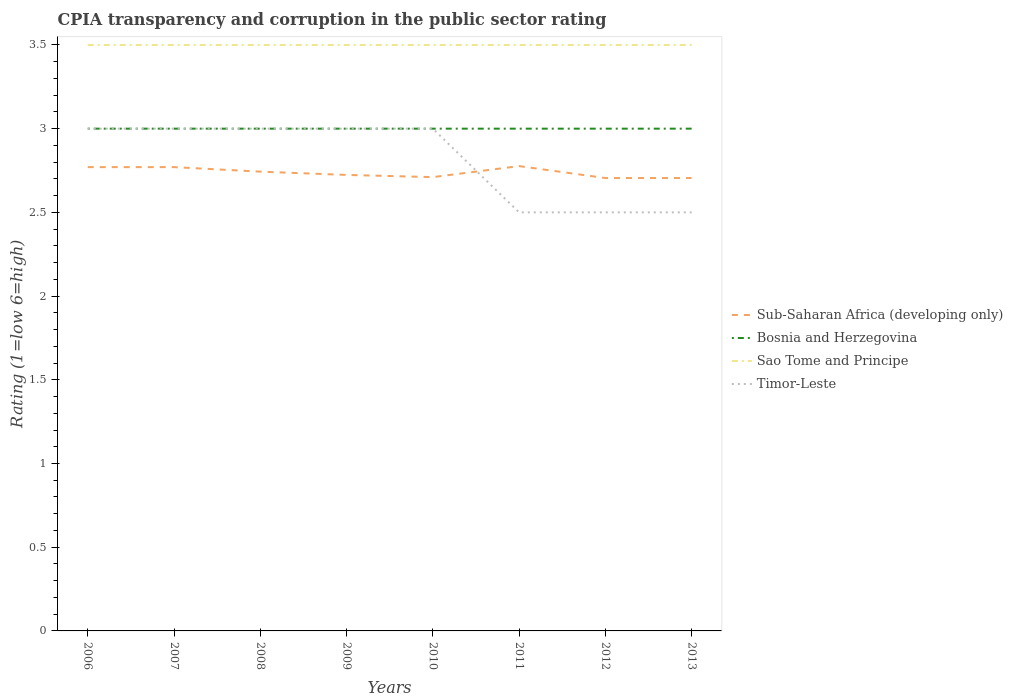Does the line corresponding to Sao Tome and Principe intersect with the line corresponding to Timor-Leste?
Offer a terse response. No. In which year was the CPIA rating in Timor-Leste maximum?
Provide a short and direct response. 2011. Is the CPIA rating in Sub-Saharan Africa (developing only) strictly greater than the CPIA rating in Bosnia and Herzegovina over the years?
Provide a succinct answer. Yes. How many years are there in the graph?
Provide a short and direct response. 8. What is the difference between two consecutive major ticks on the Y-axis?
Keep it short and to the point. 0.5. Does the graph contain grids?
Your answer should be very brief. No. How many legend labels are there?
Offer a terse response. 4. What is the title of the graph?
Provide a succinct answer. CPIA transparency and corruption in the public sector rating. Does "Tunisia" appear as one of the legend labels in the graph?
Ensure brevity in your answer.  No. What is the label or title of the X-axis?
Offer a terse response. Years. What is the label or title of the Y-axis?
Ensure brevity in your answer.  Rating (1=low 6=high). What is the Rating (1=low 6=high) of Sub-Saharan Africa (developing only) in 2006?
Provide a short and direct response. 2.77. What is the Rating (1=low 6=high) of Sao Tome and Principe in 2006?
Make the answer very short. 3.5. What is the Rating (1=low 6=high) in Sub-Saharan Africa (developing only) in 2007?
Offer a terse response. 2.77. What is the Rating (1=low 6=high) in Sao Tome and Principe in 2007?
Provide a succinct answer. 3.5. What is the Rating (1=low 6=high) of Sub-Saharan Africa (developing only) in 2008?
Your answer should be compact. 2.74. What is the Rating (1=low 6=high) in Bosnia and Herzegovina in 2008?
Give a very brief answer. 3. What is the Rating (1=low 6=high) in Sub-Saharan Africa (developing only) in 2009?
Your answer should be compact. 2.72. What is the Rating (1=low 6=high) in Bosnia and Herzegovina in 2009?
Your answer should be compact. 3. What is the Rating (1=low 6=high) of Sao Tome and Principe in 2009?
Provide a succinct answer. 3.5. What is the Rating (1=low 6=high) of Sub-Saharan Africa (developing only) in 2010?
Ensure brevity in your answer.  2.71. What is the Rating (1=low 6=high) of Bosnia and Herzegovina in 2010?
Offer a terse response. 3. What is the Rating (1=low 6=high) of Timor-Leste in 2010?
Your answer should be very brief. 3. What is the Rating (1=low 6=high) of Sub-Saharan Africa (developing only) in 2011?
Give a very brief answer. 2.78. What is the Rating (1=low 6=high) in Bosnia and Herzegovina in 2011?
Keep it short and to the point. 3. What is the Rating (1=low 6=high) in Sao Tome and Principe in 2011?
Your response must be concise. 3.5. What is the Rating (1=low 6=high) of Timor-Leste in 2011?
Offer a terse response. 2.5. What is the Rating (1=low 6=high) in Sub-Saharan Africa (developing only) in 2012?
Provide a succinct answer. 2.71. What is the Rating (1=low 6=high) in Sub-Saharan Africa (developing only) in 2013?
Offer a terse response. 2.71. What is the Rating (1=low 6=high) of Sao Tome and Principe in 2013?
Offer a terse response. 3.5. Across all years, what is the maximum Rating (1=low 6=high) of Sub-Saharan Africa (developing only)?
Make the answer very short. 2.78. Across all years, what is the maximum Rating (1=low 6=high) in Bosnia and Herzegovina?
Make the answer very short. 3. Across all years, what is the maximum Rating (1=low 6=high) of Sao Tome and Principe?
Provide a succinct answer. 3.5. Across all years, what is the maximum Rating (1=low 6=high) of Timor-Leste?
Your answer should be very brief. 3. Across all years, what is the minimum Rating (1=low 6=high) in Sub-Saharan Africa (developing only)?
Offer a terse response. 2.71. What is the total Rating (1=low 6=high) in Sub-Saharan Africa (developing only) in the graph?
Keep it short and to the point. 21.9. What is the difference between the Rating (1=low 6=high) in Sub-Saharan Africa (developing only) in 2006 and that in 2008?
Your answer should be compact. 0.03. What is the difference between the Rating (1=low 6=high) of Bosnia and Herzegovina in 2006 and that in 2008?
Provide a succinct answer. 0. What is the difference between the Rating (1=low 6=high) in Sao Tome and Principe in 2006 and that in 2008?
Ensure brevity in your answer.  0. What is the difference between the Rating (1=low 6=high) in Timor-Leste in 2006 and that in 2008?
Provide a short and direct response. 0. What is the difference between the Rating (1=low 6=high) in Sub-Saharan Africa (developing only) in 2006 and that in 2009?
Your answer should be very brief. 0.05. What is the difference between the Rating (1=low 6=high) of Bosnia and Herzegovina in 2006 and that in 2009?
Your answer should be compact. 0. What is the difference between the Rating (1=low 6=high) in Sub-Saharan Africa (developing only) in 2006 and that in 2010?
Your response must be concise. 0.06. What is the difference between the Rating (1=low 6=high) of Sao Tome and Principe in 2006 and that in 2010?
Offer a very short reply. 0. What is the difference between the Rating (1=low 6=high) of Sub-Saharan Africa (developing only) in 2006 and that in 2011?
Make the answer very short. -0.01. What is the difference between the Rating (1=low 6=high) in Bosnia and Herzegovina in 2006 and that in 2011?
Give a very brief answer. 0. What is the difference between the Rating (1=low 6=high) of Sub-Saharan Africa (developing only) in 2006 and that in 2012?
Keep it short and to the point. 0.07. What is the difference between the Rating (1=low 6=high) in Sao Tome and Principe in 2006 and that in 2012?
Offer a very short reply. 0. What is the difference between the Rating (1=low 6=high) of Timor-Leste in 2006 and that in 2012?
Give a very brief answer. 0.5. What is the difference between the Rating (1=low 6=high) in Sub-Saharan Africa (developing only) in 2006 and that in 2013?
Provide a succinct answer. 0.07. What is the difference between the Rating (1=low 6=high) in Bosnia and Herzegovina in 2006 and that in 2013?
Give a very brief answer. 0. What is the difference between the Rating (1=low 6=high) of Sao Tome and Principe in 2006 and that in 2013?
Offer a very short reply. 0. What is the difference between the Rating (1=low 6=high) of Timor-Leste in 2006 and that in 2013?
Make the answer very short. 0.5. What is the difference between the Rating (1=low 6=high) in Sub-Saharan Africa (developing only) in 2007 and that in 2008?
Your response must be concise. 0.03. What is the difference between the Rating (1=low 6=high) in Sao Tome and Principe in 2007 and that in 2008?
Offer a very short reply. 0. What is the difference between the Rating (1=low 6=high) in Timor-Leste in 2007 and that in 2008?
Provide a succinct answer. 0. What is the difference between the Rating (1=low 6=high) of Sub-Saharan Africa (developing only) in 2007 and that in 2009?
Your response must be concise. 0.05. What is the difference between the Rating (1=low 6=high) in Sao Tome and Principe in 2007 and that in 2009?
Give a very brief answer. 0. What is the difference between the Rating (1=low 6=high) in Timor-Leste in 2007 and that in 2009?
Keep it short and to the point. 0. What is the difference between the Rating (1=low 6=high) in Sub-Saharan Africa (developing only) in 2007 and that in 2010?
Your answer should be compact. 0.06. What is the difference between the Rating (1=low 6=high) in Bosnia and Herzegovina in 2007 and that in 2010?
Give a very brief answer. 0. What is the difference between the Rating (1=low 6=high) in Sao Tome and Principe in 2007 and that in 2010?
Provide a succinct answer. 0. What is the difference between the Rating (1=low 6=high) in Sub-Saharan Africa (developing only) in 2007 and that in 2011?
Offer a terse response. -0.01. What is the difference between the Rating (1=low 6=high) of Sao Tome and Principe in 2007 and that in 2011?
Ensure brevity in your answer.  0. What is the difference between the Rating (1=low 6=high) of Timor-Leste in 2007 and that in 2011?
Your response must be concise. 0.5. What is the difference between the Rating (1=low 6=high) of Sub-Saharan Africa (developing only) in 2007 and that in 2012?
Give a very brief answer. 0.07. What is the difference between the Rating (1=low 6=high) of Bosnia and Herzegovina in 2007 and that in 2012?
Keep it short and to the point. 0. What is the difference between the Rating (1=low 6=high) in Sao Tome and Principe in 2007 and that in 2012?
Provide a succinct answer. 0. What is the difference between the Rating (1=low 6=high) of Sub-Saharan Africa (developing only) in 2007 and that in 2013?
Your answer should be compact. 0.07. What is the difference between the Rating (1=low 6=high) in Sao Tome and Principe in 2007 and that in 2013?
Your response must be concise. 0. What is the difference between the Rating (1=low 6=high) in Timor-Leste in 2007 and that in 2013?
Provide a succinct answer. 0.5. What is the difference between the Rating (1=low 6=high) in Sub-Saharan Africa (developing only) in 2008 and that in 2009?
Your response must be concise. 0.02. What is the difference between the Rating (1=low 6=high) of Sub-Saharan Africa (developing only) in 2008 and that in 2010?
Your response must be concise. 0.03. What is the difference between the Rating (1=low 6=high) in Sub-Saharan Africa (developing only) in 2008 and that in 2011?
Ensure brevity in your answer.  -0.03. What is the difference between the Rating (1=low 6=high) in Bosnia and Herzegovina in 2008 and that in 2011?
Ensure brevity in your answer.  0. What is the difference between the Rating (1=low 6=high) in Sao Tome and Principe in 2008 and that in 2011?
Keep it short and to the point. 0. What is the difference between the Rating (1=low 6=high) of Timor-Leste in 2008 and that in 2011?
Keep it short and to the point. 0.5. What is the difference between the Rating (1=low 6=high) of Sub-Saharan Africa (developing only) in 2008 and that in 2012?
Offer a very short reply. 0.04. What is the difference between the Rating (1=low 6=high) in Bosnia and Herzegovina in 2008 and that in 2012?
Provide a short and direct response. 0. What is the difference between the Rating (1=low 6=high) in Sao Tome and Principe in 2008 and that in 2012?
Offer a very short reply. 0. What is the difference between the Rating (1=low 6=high) in Sub-Saharan Africa (developing only) in 2008 and that in 2013?
Keep it short and to the point. 0.04. What is the difference between the Rating (1=low 6=high) in Sao Tome and Principe in 2008 and that in 2013?
Your response must be concise. 0. What is the difference between the Rating (1=low 6=high) in Sub-Saharan Africa (developing only) in 2009 and that in 2010?
Give a very brief answer. 0.01. What is the difference between the Rating (1=low 6=high) in Bosnia and Herzegovina in 2009 and that in 2010?
Your response must be concise. 0. What is the difference between the Rating (1=low 6=high) in Sao Tome and Principe in 2009 and that in 2010?
Make the answer very short. 0. What is the difference between the Rating (1=low 6=high) in Sub-Saharan Africa (developing only) in 2009 and that in 2011?
Give a very brief answer. -0.05. What is the difference between the Rating (1=low 6=high) of Bosnia and Herzegovina in 2009 and that in 2011?
Offer a very short reply. 0. What is the difference between the Rating (1=low 6=high) of Sub-Saharan Africa (developing only) in 2009 and that in 2012?
Your answer should be compact. 0.02. What is the difference between the Rating (1=low 6=high) in Bosnia and Herzegovina in 2009 and that in 2012?
Offer a terse response. 0. What is the difference between the Rating (1=low 6=high) in Sao Tome and Principe in 2009 and that in 2012?
Your answer should be compact. 0. What is the difference between the Rating (1=low 6=high) of Sub-Saharan Africa (developing only) in 2009 and that in 2013?
Offer a very short reply. 0.02. What is the difference between the Rating (1=low 6=high) in Sao Tome and Principe in 2009 and that in 2013?
Provide a succinct answer. 0. What is the difference between the Rating (1=low 6=high) of Sub-Saharan Africa (developing only) in 2010 and that in 2011?
Provide a short and direct response. -0.07. What is the difference between the Rating (1=low 6=high) of Bosnia and Herzegovina in 2010 and that in 2011?
Keep it short and to the point. 0. What is the difference between the Rating (1=low 6=high) in Sub-Saharan Africa (developing only) in 2010 and that in 2012?
Your response must be concise. 0.01. What is the difference between the Rating (1=low 6=high) of Bosnia and Herzegovina in 2010 and that in 2012?
Keep it short and to the point. 0. What is the difference between the Rating (1=low 6=high) of Sao Tome and Principe in 2010 and that in 2012?
Make the answer very short. 0. What is the difference between the Rating (1=low 6=high) in Timor-Leste in 2010 and that in 2012?
Ensure brevity in your answer.  0.5. What is the difference between the Rating (1=low 6=high) of Sub-Saharan Africa (developing only) in 2010 and that in 2013?
Offer a very short reply. 0.01. What is the difference between the Rating (1=low 6=high) in Sub-Saharan Africa (developing only) in 2011 and that in 2012?
Give a very brief answer. 0.07. What is the difference between the Rating (1=low 6=high) in Sao Tome and Principe in 2011 and that in 2012?
Give a very brief answer. 0. What is the difference between the Rating (1=low 6=high) of Sub-Saharan Africa (developing only) in 2011 and that in 2013?
Keep it short and to the point. 0.07. What is the difference between the Rating (1=low 6=high) in Sao Tome and Principe in 2011 and that in 2013?
Provide a succinct answer. 0. What is the difference between the Rating (1=low 6=high) of Sao Tome and Principe in 2012 and that in 2013?
Your response must be concise. 0. What is the difference between the Rating (1=low 6=high) of Sub-Saharan Africa (developing only) in 2006 and the Rating (1=low 6=high) of Bosnia and Herzegovina in 2007?
Your answer should be compact. -0.23. What is the difference between the Rating (1=low 6=high) of Sub-Saharan Africa (developing only) in 2006 and the Rating (1=low 6=high) of Sao Tome and Principe in 2007?
Provide a short and direct response. -0.73. What is the difference between the Rating (1=low 6=high) in Sub-Saharan Africa (developing only) in 2006 and the Rating (1=low 6=high) in Timor-Leste in 2007?
Provide a short and direct response. -0.23. What is the difference between the Rating (1=low 6=high) in Sao Tome and Principe in 2006 and the Rating (1=low 6=high) in Timor-Leste in 2007?
Your response must be concise. 0.5. What is the difference between the Rating (1=low 6=high) in Sub-Saharan Africa (developing only) in 2006 and the Rating (1=low 6=high) in Bosnia and Herzegovina in 2008?
Keep it short and to the point. -0.23. What is the difference between the Rating (1=low 6=high) of Sub-Saharan Africa (developing only) in 2006 and the Rating (1=low 6=high) of Sao Tome and Principe in 2008?
Make the answer very short. -0.73. What is the difference between the Rating (1=low 6=high) in Sub-Saharan Africa (developing only) in 2006 and the Rating (1=low 6=high) in Timor-Leste in 2008?
Give a very brief answer. -0.23. What is the difference between the Rating (1=low 6=high) of Bosnia and Herzegovina in 2006 and the Rating (1=low 6=high) of Sao Tome and Principe in 2008?
Ensure brevity in your answer.  -0.5. What is the difference between the Rating (1=low 6=high) of Sao Tome and Principe in 2006 and the Rating (1=low 6=high) of Timor-Leste in 2008?
Your answer should be compact. 0.5. What is the difference between the Rating (1=low 6=high) of Sub-Saharan Africa (developing only) in 2006 and the Rating (1=low 6=high) of Bosnia and Herzegovina in 2009?
Keep it short and to the point. -0.23. What is the difference between the Rating (1=low 6=high) in Sub-Saharan Africa (developing only) in 2006 and the Rating (1=low 6=high) in Sao Tome and Principe in 2009?
Provide a succinct answer. -0.73. What is the difference between the Rating (1=low 6=high) of Sub-Saharan Africa (developing only) in 2006 and the Rating (1=low 6=high) of Timor-Leste in 2009?
Provide a short and direct response. -0.23. What is the difference between the Rating (1=low 6=high) of Bosnia and Herzegovina in 2006 and the Rating (1=low 6=high) of Timor-Leste in 2009?
Ensure brevity in your answer.  0. What is the difference between the Rating (1=low 6=high) of Sao Tome and Principe in 2006 and the Rating (1=low 6=high) of Timor-Leste in 2009?
Offer a terse response. 0.5. What is the difference between the Rating (1=low 6=high) of Sub-Saharan Africa (developing only) in 2006 and the Rating (1=low 6=high) of Bosnia and Herzegovina in 2010?
Your answer should be very brief. -0.23. What is the difference between the Rating (1=low 6=high) of Sub-Saharan Africa (developing only) in 2006 and the Rating (1=low 6=high) of Sao Tome and Principe in 2010?
Your answer should be compact. -0.73. What is the difference between the Rating (1=low 6=high) of Sub-Saharan Africa (developing only) in 2006 and the Rating (1=low 6=high) of Timor-Leste in 2010?
Offer a very short reply. -0.23. What is the difference between the Rating (1=low 6=high) of Sub-Saharan Africa (developing only) in 2006 and the Rating (1=low 6=high) of Bosnia and Herzegovina in 2011?
Your response must be concise. -0.23. What is the difference between the Rating (1=low 6=high) of Sub-Saharan Africa (developing only) in 2006 and the Rating (1=low 6=high) of Sao Tome and Principe in 2011?
Give a very brief answer. -0.73. What is the difference between the Rating (1=low 6=high) of Sub-Saharan Africa (developing only) in 2006 and the Rating (1=low 6=high) of Timor-Leste in 2011?
Give a very brief answer. 0.27. What is the difference between the Rating (1=low 6=high) of Bosnia and Herzegovina in 2006 and the Rating (1=low 6=high) of Timor-Leste in 2011?
Give a very brief answer. 0.5. What is the difference between the Rating (1=low 6=high) in Sao Tome and Principe in 2006 and the Rating (1=low 6=high) in Timor-Leste in 2011?
Keep it short and to the point. 1. What is the difference between the Rating (1=low 6=high) of Sub-Saharan Africa (developing only) in 2006 and the Rating (1=low 6=high) of Bosnia and Herzegovina in 2012?
Provide a succinct answer. -0.23. What is the difference between the Rating (1=low 6=high) of Sub-Saharan Africa (developing only) in 2006 and the Rating (1=low 6=high) of Sao Tome and Principe in 2012?
Give a very brief answer. -0.73. What is the difference between the Rating (1=low 6=high) of Sub-Saharan Africa (developing only) in 2006 and the Rating (1=low 6=high) of Timor-Leste in 2012?
Your response must be concise. 0.27. What is the difference between the Rating (1=low 6=high) of Bosnia and Herzegovina in 2006 and the Rating (1=low 6=high) of Sao Tome and Principe in 2012?
Your response must be concise. -0.5. What is the difference between the Rating (1=low 6=high) of Sao Tome and Principe in 2006 and the Rating (1=low 6=high) of Timor-Leste in 2012?
Ensure brevity in your answer.  1. What is the difference between the Rating (1=low 6=high) in Sub-Saharan Africa (developing only) in 2006 and the Rating (1=low 6=high) in Bosnia and Herzegovina in 2013?
Your answer should be compact. -0.23. What is the difference between the Rating (1=low 6=high) in Sub-Saharan Africa (developing only) in 2006 and the Rating (1=low 6=high) in Sao Tome and Principe in 2013?
Your response must be concise. -0.73. What is the difference between the Rating (1=low 6=high) of Sub-Saharan Africa (developing only) in 2006 and the Rating (1=low 6=high) of Timor-Leste in 2013?
Offer a very short reply. 0.27. What is the difference between the Rating (1=low 6=high) of Bosnia and Herzegovina in 2006 and the Rating (1=low 6=high) of Sao Tome and Principe in 2013?
Your answer should be compact. -0.5. What is the difference between the Rating (1=low 6=high) of Sub-Saharan Africa (developing only) in 2007 and the Rating (1=low 6=high) of Bosnia and Herzegovina in 2008?
Your answer should be very brief. -0.23. What is the difference between the Rating (1=low 6=high) of Sub-Saharan Africa (developing only) in 2007 and the Rating (1=low 6=high) of Sao Tome and Principe in 2008?
Offer a very short reply. -0.73. What is the difference between the Rating (1=low 6=high) of Sub-Saharan Africa (developing only) in 2007 and the Rating (1=low 6=high) of Timor-Leste in 2008?
Provide a short and direct response. -0.23. What is the difference between the Rating (1=low 6=high) in Bosnia and Herzegovina in 2007 and the Rating (1=low 6=high) in Timor-Leste in 2008?
Provide a succinct answer. 0. What is the difference between the Rating (1=low 6=high) in Sao Tome and Principe in 2007 and the Rating (1=low 6=high) in Timor-Leste in 2008?
Your response must be concise. 0.5. What is the difference between the Rating (1=low 6=high) of Sub-Saharan Africa (developing only) in 2007 and the Rating (1=low 6=high) of Bosnia and Herzegovina in 2009?
Ensure brevity in your answer.  -0.23. What is the difference between the Rating (1=low 6=high) of Sub-Saharan Africa (developing only) in 2007 and the Rating (1=low 6=high) of Sao Tome and Principe in 2009?
Make the answer very short. -0.73. What is the difference between the Rating (1=low 6=high) in Sub-Saharan Africa (developing only) in 2007 and the Rating (1=low 6=high) in Timor-Leste in 2009?
Your answer should be compact. -0.23. What is the difference between the Rating (1=low 6=high) of Sub-Saharan Africa (developing only) in 2007 and the Rating (1=low 6=high) of Bosnia and Herzegovina in 2010?
Your answer should be very brief. -0.23. What is the difference between the Rating (1=low 6=high) of Sub-Saharan Africa (developing only) in 2007 and the Rating (1=low 6=high) of Sao Tome and Principe in 2010?
Provide a succinct answer. -0.73. What is the difference between the Rating (1=low 6=high) in Sub-Saharan Africa (developing only) in 2007 and the Rating (1=low 6=high) in Timor-Leste in 2010?
Your response must be concise. -0.23. What is the difference between the Rating (1=low 6=high) of Bosnia and Herzegovina in 2007 and the Rating (1=low 6=high) of Timor-Leste in 2010?
Offer a very short reply. 0. What is the difference between the Rating (1=low 6=high) of Sub-Saharan Africa (developing only) in 2007 and the Rating (1=low 6=high) of Bosnia and Herzegovina in 2011?
Provide a succinct answer. -0.23. What is the difference between the Rating (1=low 6=high) of Sub-Saharan Africa (developing only) in 2007 and the Rating (1=low 6=high) of Sao Tome and Principe in 2011?
Offer a terse response. -0.73. What is the difference between the Rating (1=low 6=high) of Sub-Saharan Africa (developing only) in 2007 and the Rating (1=low 6=high) of Timor-Leste in 2011?
Make the answer very short. 0.27. What is the difference between the Rating (1=low 6=high) in Bosnia and Herzegovina in 2007 and the Rating (1=low 6=high) in Sao Tome and Principe in 2011?
Offer a terse response. -0.5. What is the difference between the Rating (1=low 6=high) of Sub-Saharan Africa (developing only) in 2007 and the Rating (1=low 6=high) of Bosnia and Herzegovina in 2012?
Ensure brevity in your answer.  -0.23. What is the difference between the Rating (1=low 6=high) of Sub-Saharan Africa (developing only) in 2007 and the Rating (1=low 6=high) of Sao Tome and Principe in 2012?
Your answer should be compact. -0.73. What is the difference between the Rating (1=low 6=high) of Sub-Saharan Africa (developing only) in 2007 and the Rating (1=low 6=high) of Timor-Leste in 2012?
Your answer should be very brief. 0.27. What is the difference between the Rating (1=low 6=high) of Bosnia and Herzegovina in 2007 and the Rating (1=low 6=high) of Timor-Leste in 2012?
Offer a terse response. 0.5. What is the difference between the Rating (1=low 6=high) in Sub-Saharan Africa (developing only) in 2007 and the Rating (1=low 6=high) in Bosnia and Herzegovina in 2013?
Ensure brevity in your answer.  -0.23. What is the difference between the Rating (1=low 6=high) in Sub-Saharan Africa (developing only) in 2007 and the Rating (1=low 6=high) in Sao Tome and Principe in 2013?
Provide a short and direct response. -0.73. What is the difference between the Rating (1=low 6=high) of Sub-Saharan Africa (developing only) in 2007 and the Rating (1=low 6=high) of Timor-Leste in 2013?
Your answer should be very brief. 0.27. What is the difference between the Rating (1=low 6=high) in Bosnia and Herzegovina in 2007 and the Rating (1=low 6=high) in Timor-Leste in 2013?
Ensure brevity in your answer.  0.5. What is the difference between the Rating (1=low 6=high) in Sao Tome and Principe in 2007 and the Rating (1=low 6=high) in Timor-Leste in 2013?
Offer a very short reply. 1. What is the difference between the Rating (1=low 6=high) in Sub-Saharan Africa (developing only) in 2008 and the Rating (1=low 6=high) in Bosnia and Herzegovina in 2009?
Provide a succinct answer. -0.26. What is the difference between the Rating (1=low 6=high) of Sub-Saharan Africa (developing only) in 2008 and the Rating (1=low 6=high) of Sao Tome and Principe in 2009?
Make the answer very short. -0.76. What is the difference between the Rating (1=low 6=high) in Sub-Saharan Africa (developing only) in 2008 and the Rating (1=low 6=high) in Timor-Leste in 2009?
Ensure brevity in your answer.  -0.26. What is the difference between the Rating (1=low 6=high) in Sao Tome and Principe in 2008 and the Rating (1=low 6=high) in Timor-Leste in 2009?
Your answer should be compact. 0.5. What is the difference between the Rating (1=low 6=high) of Sub-Saharan Africa (developing only) in 2008 and the Rating (1=low 6=high) of Bosnia and Herzegovina in 2010?
Give a very brief answer. -0.26. What is the difference between the Rating (1=low 6=high) in Sub-Saharan Africa (developing only) in 2008 and the Rating (1=low 6=high) in Sao Tome and Principe in 2010?
Provide a short and direct response. -0.76. What is the difference between the Rating (1=low 6=high) of Sub-Saharan Africa (developing only) in 2008 and the Rating (1=low 6=high) of Timor-Leste in 2010?
Give a very brief answer. -0.26. What is the difference between the Rating (1=low 6=high) of Bosnia and Herzegovina in 2008 and the Rating (1=low 6=high) of Timor-Leste in 2010?
Offer a terse response. 0. What is the difference between the Rating (1=low 6=high) in Sao Tome and Principe in 2008 and the Rating (1=low 6=high) in Timor-Leste in 2010?
Make the answer very short. 0.5. What is the difference between the Rating (1=low 6=high) of Sub-Saharan Africa (developing only) in 2008 and the Rating (1=low 6=high) of Bosnia and Herzegovina in 2011?
Offer a very short reply. -0.26. What is the difference between the Rating (1=low 6=high) of Sub-Saharan Africa (developing only) in 2008 and the Rating (1=low 6=high) of Sao Tome and Principe in 2011?
Provide a short and direct response. -0.76. What is the difference between the Rating (1=low 6=high) of Sub-Saharan Africa (developing only) in 2008 and the Rating (1=low 6=high) of Timor-Leste in 2011?
Offer a very short reply. 0.24. What is the difference between the Rating (1=low 6=high) of Bosnia and Herzegovina in 2008 and the Rating (1=low 6=high) of Sao Tome and Principe in 2011?
Your response must be concise. -0.5. What is the difference between the Rating (1=low 6=high) in Sub-Saharan Africa (developing only) in 2008 and the Rating (1=low 6=high) in Bosnia and Herzegovina in 2012?
Give a very brief answer. -0.26. What is the difference between the Rating (1=low 6=high) in Sub-Saharan Africa (developing only) in 2008 and the Rating (1=low 6=high) in Sao Tome and Principe in 2012?
Your answer should be very brief. -0.76. What is the difference between the Rating (1=low 6=high) in Sub-Saharan Africa (developing only) in 2008 and the Rating (1=low 6=high) in Timor-Leste in 2012?
Keep it short and to the point. 0.24. What is the difference between the Rating (1=low 6=high) in Bosnia and Herzegovina in 2008 and the Rating (1=low 6=high) in Sao Tome and Principe in 2012?
Ensure brevity in your answer.  -0.5. What is the difference between the Rating (1=low 6=high) of Bosnia and Herzegovina in 2008 and the Rating (1=low 6=high) of Timor-Leste in 2012?
Offer a very short reply. 0.5. What is the difference between the Rating (1=low 6=high) in Sub-Saharan Africa (developing only) in 2008 and the Rating (1=low 6=high) in Bosnia and Herzegovina in 2013?
Provide a short and direct response. -0.26. What is the difference between the Rating (1=low 6=high) in Sub-Saharan Africa (developing only) in 2008 and the Rating (1=low 6=high) in Sao Tome and Principe in 2013?
Offer a terse response. -0.76. What is the difference between the Rating (1=low 6=high) in Sub-Saharan Africa (developing only) in 2008 and the Rating (1=low 6=high) in Timor-Leste in 2013?
Provide a short and direct response. 0.24. What is the difference between the Rating (1=low 6=high) in Bosnia and Herzegovina in 2008 and the Rating (1=low 6=high) in Timor-Leste in 2013?
Provide a short and direct response. 0.5. What is the difference between the Rating (1=low 6=high) in Sub-Saharan Africa (developing only) in 2009 and the Rating (1=low 6=high) in Bosnia and Herzegovina in 2010?
Provide a succinct answer. -0.28. What is the difference between the Rating (1=low 6=high) in Sub-Saharan Africa (developing only) in 2009 and the Rating (1=low 6=high) in Sao Tome and Principe in 2010?
Offer a terse response. -0.78. What is the difference between the Rating (1=low 6=high) in Sub-Saharan Africa (developing only) in 2009 and the Rating (1=low 6=high) in Timor-Leste in 2010?
Your response must be concise. -0.28. What is the difference between the Rating (1=low 6=high) of Bosnia and Herzegovina in 2009 and the Rating (1=low 6=high) of Timor-Leste in 2010?
Your answer should be very brief. 0. What is the difference between the Rating (1=low 6=high) in Sub-Saharan Africa (developing only) in 2009 and the Rating (1=low 6=high) in Bosnia and Herzegovina in 2011?
Offer a terse response. -0.28. What is the difference between the Rating (1=low 6=high) in Sub-Saharan Africa (developing only) in 2009 and the Rating (1=low 6=high) in Sao Tome and Principe in 2011?
Your answer should be very brief. -0.78. What is the difference between the Rating (1=low 6=high) in Sub-Saharan Africa (developing only) in 2009 and the Rating (1=low 6=high) in Timor-Leste in 2011?
Provide a succinct answer. 0.22. What is the difference between the Rating (1=low 6=high) in Bosnia and Herzegovina in 2009 and the Rating (1=low 6=high) in Timor-Leste in 2011?
Provide a succinct answer. 0.5. What is the difference between the Rating (1=low 6=high) in Sao Tome and Principe in 2009 and the Rating (1=low 6=high) in Timor-Leste in 2011?
Give a very brief answer. 1. What is the difference between the Rating (1=low 6=high) in Sub-Saharan Africa (developing only) in 2009 and the Rating (1=low 6=high) in Bosnia and Herzegovina in 2012?
Your answer should be very brief. -0.28. What is the difference between the Rating (1=low 6=high) of Sub-Saharan Africa (developing only) in 2009 and the Rating (1=low 6=high) of Sao Tome and Principe in 2012?
Your answer should be compact. -0.78. What is the difference between the Rating (1=low 6=high) of Sub-Saharan Africa (developing only) in 2009 and the Rating (1=low 6=high) of Timor-Leste in 2012?
Provide a short and direct response. 0.22. What is the difference between the Rating (1=low 6=high) in Sao Tome and Principe in 2009 and the Rating (1=low 6=high) in Timor-Leste in 2012?
Offer a very short reply. 1. What is the difference between the Rating (1=low 6=high) of Sub-Saharan Africa (developing only) in 2009 and the Rating (1=low 6=high) of Bosnia and Herzegovina in 2013?
Your answer should be compact. -0.28. What is the difference between the Rating (1=low 6=high) of Sub-Saharan Africa (developing only) in 2009 and the Rating (1=low 6=high) of Sao Tome and Principe in 2013?
Offer a very short reply. -0.78. What is the difference between the Rating (1=low 6=high) in Sub-Saharan Africa (developing only) in 2009 and the Rating (1=low 6=high) in Timor-Leste in 2013?
Your response must be concise. 0.22. What is the difference between the Rating (1=low 6=high) in Sub-Saharan Africa (developing only) in 2010 and the Rating (1=low 6=high) in Bosnia and Herzegovina in 2011?
Your response must be concise. -0.29. What is the difference between the Rating (1=low 6=high) of Sub-Saharan Africa (developing only) in 2010 and the Rating (1=low 6=high) of Sao Tome and Principe in 2011?
Provide a short and direct response. -0.79. What is the difference between the Rating (1=low 6=high) in Sub-Saharan Africa (developing only) in 2010 and the Rating (1=low 6=high) in Timor-Leste in 2011?
Your response must be concise. 0.21. What is the difference between the Rating (1=low 6=high) in Bosnia and Herzegovina in 2010 and the Rating (1=low 6=high) in Sao Tome and Principe in 2011?
Offer a very short reply. -0.5. What is the difference between the Rating (1=low 6=high) in Bosnia and Herzegovina in 2010 and the Rating (1=low 6=high) in Timor-Leste in 2011?
Provide a succinct answer. 0.5. What is the difference between the Rating (1=low 6=high) in Sub-Saharan Africa (developing only) in 2010 and the Rating (1=low 6=high) in Bosnia and Herzegovina in 2012?
Keep it short and to the point. -0.29. What is the difference between the Rating (1=low 6=high) of Sub-Saharan Africa (developing only) in 2010 and the Rating (1=low 6=high) of Sao Tome and Principe in 2012?
Offer a terse response. -0.79. What is the difference between the Rating (1=low 6=high) of Sub-Saharan Africa (developing only) in 2010 and the Rating (1=low 6=high) of Timor-Leste in 2012?
Keep it short and to the point. 0.21. What is the difference between the Rating (1=low 6=high) of Bosnia and Herzegovina in 2010 and the Rating (1=low 6=high) of Timor-Leste in 2012?
Offer a terse response. 0.5. What is the difference between the Rating (1=low 6=high) of Sao Tome and Principe in 2010 and the Rating (1=low 6=high) of Timor-Leste in 2012?
Keep it short and to the point. 1. What is the difference between the Rating (1=low 6=high) of Sub-Saharan Africa (developing only) in 2010 and the Rating (1=low 6=high) of Bosnia and Herzegovina in 2013?
Make the answer very short. -0.29. What is the difference between the Rating (1=low 6=high) in Sub-Saharan Africa (developing only) in 2010 and the Rating (1=low 6=high) in Sao Tome and Principe in 2013?
Offer a terse response. -0.79. What is the difference between the Rating (1=low 6=high) of Sub-Saharan Africa (developing only) in 2010 and the Rating (1=low 6=high) of Timor-Leste in 2013?
Provide a succinct answer. 0.21. What is the difference between the Rating (1=low 6=high) in Bosnia and Herzegovina in 2010 and the Rating (1=low 6=high) in Timor-Leste in 2013?
Your answer should be compact. 0.5. What is the difference between the Rating (1=low 6=high) in Sub-Saharan Africa (developing only) in 2011 and the Rating (1=low 6=high) in Bosnia and Herzegovina in 2012?
Provide a succinct answer. -0.22. What is the difference between the Rating (1=low 6=high) in Sub-Saharan Africa (developing only) in 2011 and the Rating (1=low 6=high) in Sao Tome and Principe in 2012?
Offer a very short reply. -0.72. What is the difference between the Rating (1=low 6=high) in Sub-Saharan Africa (developing only) in 2011 and the Rating (1=low 6=high) in Timor-Leste in 2012?
Give a very brief answer. 0.28. What is the difference between the Rating (1=low 6=high) in Bosnia and Herzegovina in 2011 and the Rating (1=low 6=high) in Timor-Leste in 2012?
Your answer should be compact. 0.5. What is the difference between the Rating (1=low 6=high) in Sao Tome and Principe in 2011 and the Rating (1=low 6=high) in Timor-Leste in 2012?
Your answer should be very brief. 1. What is the difference between the Rating (1=low 6=high) of Sub-Saharan Africa (developing only) in 2011 and the Rating (1=low 6=high) of Bosnia and Herzegovina in 2013?
Your answer should be very brief. -0.22. What is the difference between the Rating (1=low 6=high) in Sub-Saharan Africa (developing only) in 2011 and the Rating (1=low 6=high) in Sao Tome and Principe in 2013?
Your response must be concise. -0.72. What is the difference between the Rating (1=low 6=high) of Sub-Saharan Africa (developing only) in 2011 and the Rating (1=low 6=high) of Timor-Leste in 2013?
Your response must be concise. 0.28. What is the difference between the Rating (1=low 6=high) in Bosnia and Herzegovina in 2011 and the Rating (1=low 6=high) in Timor-Leste in 2013?
Keep it short and to the point. 0.5. What is the difference between the Rating (1=low 6=high) of Sao Tome and Principe in 2011 and the Rating (1=low 6=high) of Timor-Leste in 2013?
Make the answer very short. 1. What is the difference between the Rating (1=low 6=high) in Sub-Saharan Africa (developing only) in 2012 and the Rating (1=low 6=high) in Bosnia and Herzegovina in 2013?
Give a very brief answer. -0.29. What is the difference between the Rating (1=low 6=high) of Sub-Saharan Africa (developing only) in 2012 and the Rating (1=low 6=high) of Sao Tome and Principe in 2013?
Keep it short and to the point. -0.79. What is the difference between the Rating (1=low 6=high) of Sub-Saharan Africa (developing only) in 2012 and the Rating (1=low 6=high) of Timor-Leste in 2013?
Give a very brief answer. 0.21. What is the average Rating (1=low 6=high) of Sub-Saharan Africa (developing only) per year?
Provide a short and direct response. 2.74. What is the average Rating (1=low 6=high) in Bosnia and Herzegovina per year?
Your response must be concise. 3. What is the average Rating (1=low 6=high) of Sao Tome and Principe per year?
Your answer should be very brief. 3.5. What is the average Rating (1=low 6=high) of Timor-Leste per year?
Your response must be concise. 2.81. In the year 2006, what is the difference between the Rating (1=low 6=high) in Sub-Saharan Africa (developing only) and Rating (1=low 6=high) in Bosnia and Herzegovina?
Make the answer very short. -0.23. In the year 2006, what is the difference between the Rating (1=low 6=high) of Sub-Saharan Africa (developing only) and Rating (1=low 6=high) of Sao Tome and Principe?
Give a very brief answer. -0.73. In the year 2006, what is the difference between the Rating (1=low 6=high) in Sub-Saharan Africa (developing only) and Rating (1=low 6=high) in Timor-Leste?
Provide a short and direct response. -0.23. In the year 2006, what is the difference between the Rating (1=low 6=high) of Bosnia and Herzegovina and Rating (1=low 6=high) of Timor-Leste?
Give a very brief answer. 0. In the year 2007, what is the difference between the Rating (1=low 6=high) in Sub-Saharan Africa (developing only) and Rating (1=low 6=high) in Bosnia and Herzegovina?
Keep it short and to the point. -0.23. In the year 2007, what is the difference between the Rating (1=low 6=high) in Sub-Saharan Africa (developing only) and Rating (1=low 6=high) in Sao Tome and Principe?
Offer a terse response. -0.73. In the year 2007, what is the difference between the Rating (1=low 6=high) of Sub-Saharan Africa (developing only) and Rating (1=low 6=high) of Timor-Leste?
Offer a very short reply. -0.23. In the year 2007, what is the difference between the Rating (1=low 6=high) of Bosnia and Herzegovina and Rating (1=low 6=high) of Sao Tome and Principe?
Your response must be concise. -0.5. In the year 2007, what is the difference between the Rating (1=low 6=high) in Sao Tome and Principe and Rating (1=low 6=high) in Timor-Leste?
Provide a succinct answer. 0.5. In the year 2008, what is the difference between the Rating (1=low 6=high) of Sub-Saharan Africa (developing only) and Rating (1=low 6=high) of Bosnia and Herzegovina?
Your answer should be compact. -0.26. In the year 2008, what is the difference between the Rating (1=low 6=high) in Sub-Saharan Africa (developing only) and Rating (1=low 6=high) in Sao Tome and Principe?
Ensure brevity in your answer.  -0.76. In the year 2008, what is the difference between the Rating (1=low 6=high) of Sub-Saharan Africa (developing only) and Rating (1=low 6=high) of Timor-Leste?
Keep it short and to the point. -0.26. In the year 2008, what is the difference between the Rating (1=low 6=high) of Bosnia and Herzegovina and Rating (1=low 6=high) of Timor-Leste?
Provide a succinct answer. 0. In the year 2008, what is the difference between the Rating (1=low 6=high) in Sao Tome and Principe and Rating (1=low 6=high) in Timor-Leste?
Your response must be concise. 0.5. In the year 2009, what is the difference between the Rating (1=low 6=high) of Sub-Saharan Africa (developing only) and Rating (1=low 6=high) of Bosnia and Herzegovina?
Your response must be concise. -0.28. In the year 2009, what is the difference between the Rating (1=low 6=high) of Sub-Saharan Africa (developing only) and Rating (1=low 6=high) of Sao Tome and Principe?
Ensure brevity in your answer.  -0.78. In the year 2009, what is the difference between the Rating (1=low 6=high) in Sub-Saharan Africa (developing only) and Rating (1=low 6=high) in Timor-Leste?
Offer a very short reply. -0.28. In the year 2010, what is the difference between the Rating (1=low 6=high) in Sub-Saharan Africa (developing only) and Rating (1=low 6=high) in Bosnia and Herzegovina?
Offer a very short reply. -0.29. In the year 2010, what is the difference between the Rating (1=low 6=high) of Sub-Saharan Africa (developing only) and Rating (1=low 6=high) of Sao Tome and Principe?
Offer a terse response. -0.79. In the year 2010, what is the difference between the Rating (1=low 6=high) of Sub-Saharan Africa (developing only) and Rating (1=low 6=high) of Timor-Leste?
Offer a very short reply. -0.29. In the year 2010, what is the difference between the Rating (1=low 6=high) in Sao Tome and Principe and Rating (1=low 6=high) in Timor-Leste?
Keep it short and to the point. 0.5. In the year 2011, what is the difference between the Rating (1=low 6=high) of Sub-Saharan Africa (developing only) and Rating (1=low 6=high) of Bosnia and Herzegovina?
Your answer should be very brief. -0.22. In the year 2011, what is the difference between the Rating (1=low 6=high) of Sub-Saharan Africa (developing only) and Rating (1=low 6=high) of Sao Tome and Principe?
Ensure brevity in your answer.  -0.72. In the year 2011, what is the difference between the Rating (1=low 6=high) in Sub-Saharan Africa (developing only) and Rating (1=low 6=high) in Timor-Leste?
Your answer should be very brief. 0.28. In the year 2011, what is the difference between the Rating (1=low 6=high) in Bosnia and Herzegovina and Rating (1=low 6=high) in Sao Tome and Principe?
Keep it short and to the point. -0.5. In the year 2012, what is the difference between the Rating (1=low 6=high) of Sub-Saharan Africa (developing only) and Rating (1=low 6=high) of Bosnia and Herzegovina?
Give a very brief answer. -0.29. In the year 2012, what is the difference between the Rating (1=low 6=high) of Sub-Saharan Africa (developing only) and Rating (1=low 6=high) of Sao Tome and Principe?
Offer a terse response. -0.79. In the year 2012, what is the difference between the Rating (1=low 6=high) in Sub-Saharan Africa (developing only) and Rating (1=low 6=high) in Timor-Leste?
Give a very brief answer. 0.21. In the year 2012, what is the difference between the Rating (1=low 6=high) of Bosnia and Herzegovina and Rating (1=low 6=high) of Timor-Leste?
Give a very brief answer. 0.5. In the year 2012, what is the difference between the Rating (1=low 6=high) of Sao Tome and Principe and Rating (1=low 6=high) of Timor-Leste?
Provide a short and direct response. 1. In the year 2013, what is the difference between the Rating (1=low 6=high) in Sub-Saharan Africa (developing only) and Rating (1=low 6=high) in Bosnia and Herzegovina?
Your answer should be very brief. -0.29. In the year 2013, what is the difference between the Rating (1=low 6=high) of Sub-Saharan Africa (developing only) and Rating (1=low 6=high) of Sao Tome and Principe?
Ensure brevity in your answer.  -0.79. In the year 2013, what is the difference between the Rating (1=low 6=high) of Sub-Saharan Africa (developing only) and Rating (1=low 6=high) of Timor-Leste?
Make the answer very short. 0.21. In the year 2013, what is the difference between the Rating (1=low 6=high) in Bosnia and Herzegovina and Rating (1=low 6=high) in Sao Tome and Principe?
Your answer should be compact. -0.5. In the year 2013, what is the difference between the Rating (1=low 6=high) in Sao Tome and Principe and Rating (1=low 6=high) in Timor-Leste?
Provide a short and direct response. 1. What is the ratio of the Rating (1=low 6=high) in Sub-Saharan Africa (developing only) in 2006 to that in 2007?
Offer a very short reply. 1. What is the ratio of the Rating (1=low 6=high) in Bosnia and Herzegovina in 2006 to that in 2007?
Ensure brevity in your answer.  1. What is the ratio of the Rating (1=low 6=high) in Sub-Saharan Africa (developing only) in 2006 to that in 2008?
Your answer should be compact. 1.01. What is the ratio of the Rating (1=low 6=high) in Bosnia and Herzegovina in 2006 to that in 2008?
Provide a short and direct response. 1. What is the ratio of the Rating (1=low 6=high) in Sao Tome and Principe in 2006 to that in 2008?
Keep it short and to the point. 1. What is the ratio of the Rating (1=low 6=high) of Sub-Saharan Africa (developing only) in 2006 to that in 2009?
Offer a very short reply. 1.02. What is the ratio of the Rating (1=low 6=high) of Bosnia and Herzegovina in 2006 to that in 2009?
Your answer should be compact. 1. What is the ratio of the Rating (1=low 6=high) in Timor-Leste in 2006 to that in 2009?
Your answer should be compact. 1. What is the ratio of the Rating (1=low 6=high) in Sub-Saharan Africa (developing only) in 2006 to that in 2010?
Make the answer very short. 1.02. What is the ratio of the Rating (1=low 6=high) in Timor-Leste in 2006 to that in 2010?
Give a very brief answer. 1. What is the ratio of the Rating (1=low 6=high) in Sub-Saharan Africa (developing only) in 2006 to that in 2011?
Provide a short and direct response. 1. What is the ratio of the Rating (1=low 6=high) in Bosnia and Herzegovina in 2006 to that in 2011?
Provide a succinct answer. 1. What is the ratio of the Rating (1=low 6=high) of Timor-Leste in 2006 to that in 2011?
Make the answer very short. 1.2. What is the ratio of the Rating (1=low 6=high) in Sub-Saharan Africa (developing only) in 2006 to that in 2012?
Give a very brief answer. 1.02. What is the ratio of the Rating (1=low 6=high) in Sao Tome and Principe in 2006 to that in 2012?
Make the answer very short. 1. What is the ratio of the Rating (1=low 6=high) in Sub-Saharan Africa (developing only) in 2006 to that in 2013?
Provide a short and direct response. 1.02. What is the ratio of the Rating (1=low 6=high) of Sub-Saharan Africa (developing only) in 2007 to that in 2008?
Provide a succinct answer. 1.01. What is the ratio of the Rating (1=low 6=high) of Bosnia and Herzegovina in 2007 to that in 2008?
Your response must be concise. 1. What is the ratio of the Rating (1=low 6=high) in Sao Tome and Principe in 2007 to that in 2008?
Give a very brief answer. 1. What is the ratio of the Rating (1=low 6=high) in Sub-Saharan Africa (developing only) in 2007 to that in 2009?
Your response must be concise. 1.02. What is the ratio of the Rating (1=low 6=high) in Bosnia and Herzegovina in 2007 to that in 2009?
Offer a very short reply. 1. What is the ratio of the Rating (1=low 6=high) in Timor-Leste in 2007 to that in 2009?
Your answer should be compact. 1. What is the ratio of the Rating (1=low 6=high) of Sao Tome and Principe in 2007 to that in 2010?
Give a very brief answer. 1. What is the ratio of the Rating (1=low 6=high) in Sub-Saharan Africa (developing only) in 2007 to that in 2012?
Offer a terse response. 1.02. What is the ratio of the Rating (1=low 6=high) of Bosnia and Herzegovina in 2007 to that in 2012?
Keep it short and to the point. 1. What is the ratio of the Rating (1=low 6=high) in Timor-Leste in 2007 to that in 2012?
Provide a succinct answer. 1.2. What is the ratio of the Rating (1=low 6=high) in Sub-Saharan Africa (developing only) in 2007 to that in 2013?
Your answer should be very brief. 1.02. What is the ratio of the Rating (1=low 6=high) in Bosnia and Herzegovina in 2007 to that in 2013?
Ensure brevity in your answer.  1. What is the ratio of the Rating (1=low 6=high) of Timor-Leste in 2007 to that in 2013?
Provide a short and direct response. 1.2. What is the ratio of the Rating (1=low 6=high) in Sub-Saharan Africa (developing only) in 2008 to that in 2009?
Your answer should be very brief. 1.01. What is the ratio of the Rating (1=low 6=high) of Sub-Saharan Africa (developing only) in 2008 to that in 2010?
Make the answer very short. 1.01. What is the ratio of the Rating (1=low 6=high) of Sao Tome and Principe in 2008 to that in 2010?
Provide a succinct answer. 1. What is the ratio of the Rating (1=low 6=high) in Timor-Leste in 2008 to that in 2010?
Your answer should be compact. 1. What is the ratio of the Rating (1=low 6=high) of Sub-Saharan Africa (developing only) in 2008 to that in 2011?
Provide a short and direct response. 0.99. What is the ratio of the Rating (1=low 6=high) of Bosnia and Herzegovina in 2008 to that in 2011?
Provide a succinct answer. 1. What is the ratio of the Rating (1=low 6=high) in Timor-Leste in 2008 to that in 2011?
Your answer should be compact. 1.2. What is the ratio of the Rating (1=low 6=high) in Sub-Saharan Africa (developing only) in 2008 to that in 2012?
Give a very brief answer. 1.01. What is the ratio of the Rating (1=low 6=high) in Sub-Saharan Africa (developing only) in 2008 to that in 2013?
Make the answer very short. 1.01. What is the ratio of the Rating (1=low 6=high) in Sao Tome and Principe in 2008 to that in 2013?
Ensure brevity in your answer.  1. What is the ratio of the Rating (1=low 6=high) in Sub-Saharan Africa (developing only) in 2009 to that in 2010?
Ensure brevity in your answer.  1. What is the ratio of the Rating (1=low 6=high) of Bosnia and Herzegovina in 2009 to that in 2010?
Ensure brevity in your answer.  1. What is the ratio of the Rating (1=low 6=high) in Sao Tome and Principe in 2009 to that in 2010?
Offer a terse response. 1. What is the ratio of the Rating (1=low 6=high) of Timor-Leste in 2009 to that in 2010?
Your answer should be compact. 1. What is the ratio of the Rating (1=low 6=high) in Sao Tome and Principe in 2009 to that in 2012?
Make the answer very short. 1. What is the ratio of the Rating (1=low 6=high) in Sub-Saharan Africa (developing only) in 2009 to that in 2013?
Offer a terse response. 1.01. What is the ratio of the Rating (1=low 6=high) of Bosnia and Herzegovina in 2009 to that in 2013?
Your answer should be compact. 1. What is the ratio of the Rating (1=low 6=high) of Sao Tome and Principe in 2009 to that in 2013?
Provide a short and direct response. 1. What is the ratio of the Rating (1=low 6=high) in Timor-Leste in 2009 to that in 2013?
Your answer should be very brief. 1.2. What is the ratio of the Rating (1=low 6=high) of Sub-Saharan Africa (developing only) in 2010 to that in 2011?
Your answer should be very brief. 0.98. What is the ratio of the Rating (1=low 6=high) in Timor-Leste in 2010 to that in 2011?
Provide a succinct answer. 1.2. What is the ratio of the Rating (1=low 6=high) of Sub-Saharan Africa (developing only) in 2010 to that in 2012?
Offer a terse response. 1. What is the ratio of the Rating (1=low 6=high) in Bosnia and Herzegovina in 2010 to that in 2012?
Give a very brief answer. 1. What is the ratio of the Rating (1=low 6=high) of Sao Tome and Principe in 2010 to that in 2012?
Make the answer very short. 1. What is the ratio of the Rating (1=low 6=high) of Bosnia and Herzegovina in 2010 to that in 2013?
Your answer should be compact. 1. What is the ratio of the Rating (1=low 6=high) of Sao Tome and Principe in 2010 to that in 2013?
Offer a very short reply. 1. What is the ratio of the Rating (1=low 6=high) in Sub-Saharan Africa (developing only) in 2011 to that in 2012?
Your answer should be very brief. 1.03. What is the ratio of the Rating (1=low 6=high) of Sub-Saharan Africa (developing only) in 2011 to that in 2013?
Offer a very short reply. 1.03. What is the ratio of the Rating (1=low 6=high) in Bosnia and Herzegovina in 2011 to that in 2013?
Make the answer very short. 1. What is the ratio of the Rating (1=low 6=high) of Sub-Saharan Africa (developing only) in 2012 to that in 2013?
Offer a terse response. 1. What is the ratio of the Rating (1=low 6=high) in Bosnia and Herzegovina in 2012 to that in 2013?
Give a very brief answer. 1. What is the ratio of the Rating (1=low 6=high) in Sao Tome and Principe in 2012 to that in 2013?
Make the answer very short. 1. What is the difference between the highest and the second highest Rating (1=low 6=high) in Sub-Saharan Africa (developing only)?
Your answer should be very brief. 0.01. What is the difference between the highest and the second highest Rating (1=low 6=high) of Bosnia and Herzegovina?
Offer a very short reply. 0. What is the difference between the highest and the lowest Rating (1=low 6=high) in Sub-Saharan Africa (developing only)?
Your answer should be compact. 0.07. What is the difference between the highest and the lowest Rating (1=low 6=high) of Bosnia and Herzegovina?
Offer a very short reply. 0. 